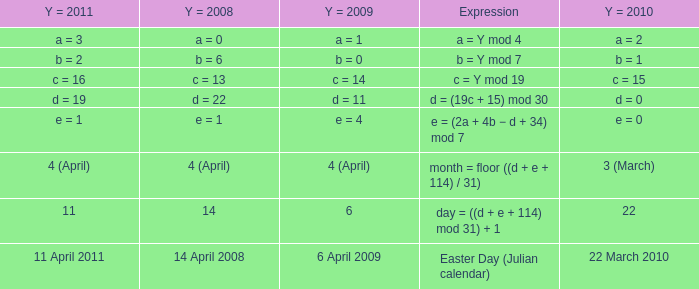What is the y = 2011 when the y = 2009 is 6 april 2009? 11 April 2011. 